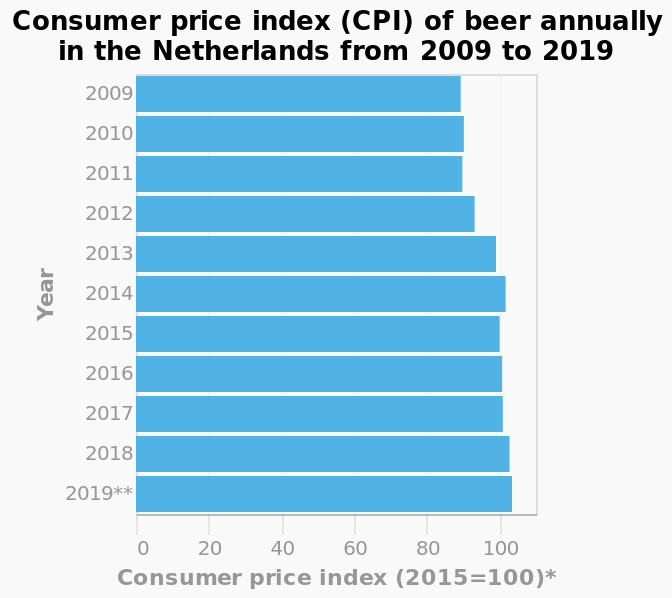<image>
When does the CPI of beer in the Netherlands begin to increase? The CPI of beer in the Netherlands begins to increase after 2009. When does the CPI of beer in the Netherlands begin to decrease again? The CPI of beer in the Netherlands begins to decrease again after 2014. What is the CPI of beer in the Netherlands in 2009? The CPI of beer in the Netherlands in 2009 is 85. 